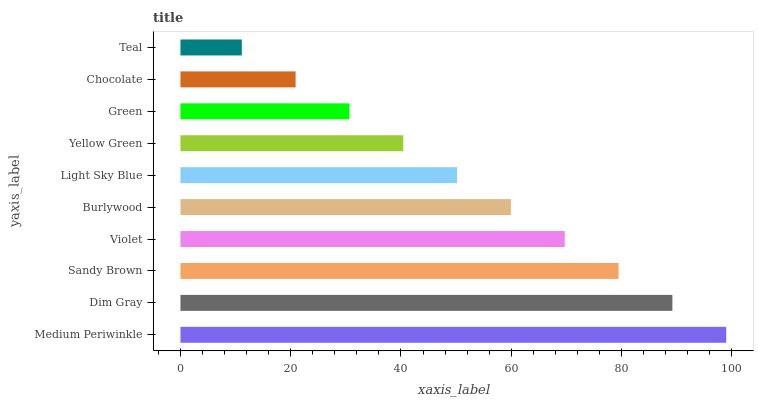Is Teal the minimum?
Answer yes or no. Yes. Is Medium Periwinkle the maximum?
Answer yes or no. Yes. Is Dim Gray the minimum?
Answer yes or no. No. Is Dim Gray the maximum?
Answer yes or no. No. Is Medium Periwinkle greater than Dim Gray?
Answer yes or no. Yes. Is Dim Gray less than Medium Periwinkle?
Answer yes or no. Yes. Is Dim Gray greater than Medium Periwinkle?
Answer yes or no. No. Is Medium Periwinkle less than Dim Gray?
Answer yes or no. No. Is Burlywood the high median?
Answer yes or no. Yes. Is Light Sky Blue the low median?
Answer yes or no. Yes. Is Light Sky Blue the high median?
Answer yes or no. No. Is Violet the low median?
Answer yes or no. No. 